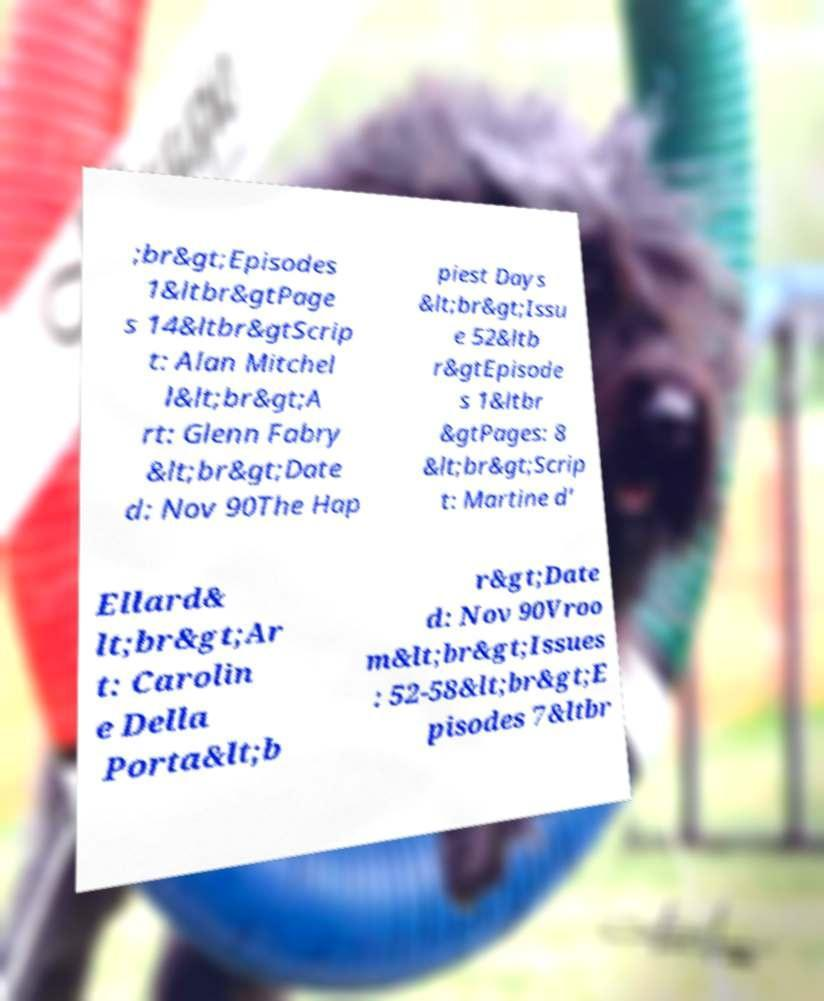Can you read and provide the text displayed in the image?This photo seems to have some interesting text. Can you extract and type it out for me? ;br&gt;Episodes 1&ltbr&gtPage s 14&ltbr&gtScrip t: Alan Mitchel l&lt;br&gt;A rt: Glenn Fabry &lt;br&gt;Date d: Nov 90The Hap piest Days &lt;br&gt;Issu e 52&ltb r&gtEpisode s 1&ltbr &gtPages: 8 &lt;br&gt;Scrip t: Martine d’ Ellard& lt;br&gt;Ar t: Carolin e Della Porta&lt;b r&gt;Date d: Nov 90Vroo m&lt;br&gt;Issues : 52-58&lt;br&gt;E pisodes 7&ltbr 